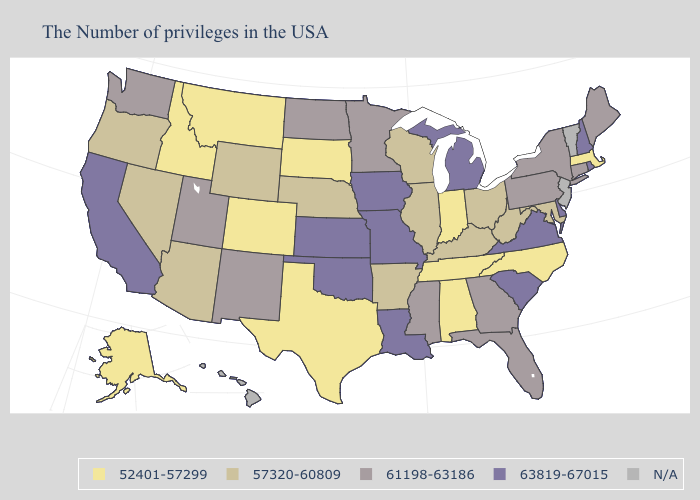Name the states that have a value in the range 57320-60809?
Quick response, please. Maryland, West Virginia, Ohio, Kentucky, Wisconsin, Illinois, Arkansas, Nebraska, Wyoming, Arizona, Nevada, Oregon. Does Pennsylvania have the highest value in the Northeast?
Answer briefly. No. What is the lowest value in the West?
Concise answer only. 52401-57299. Name the states that have a value in the range 52401-57299?
Keep it brief. Massachusetts, North Carolina, Indiana, Alabama, Tennessee, Texas, South Dakota, Colorado, Montana, Idaho, Alaska. Is the legend a continuous bar?
Write a very short answer. No. What is the lowest value in states that border North Carolina?
Write a very short answer. 52401-57299. What is the value of Delaware?
Write a very short answer. 63819-67015. Does South Carolina have the lowest value in the South?
Keep it brief. No. Does Indiana have the lowest value in the USA?
Quick response, please. Yes. Among the states that border Alabama , which have the lowest value?
Short answer required. Tennessee. What is the value of Wisconsin?
Concise answer only. 57320-60809. Name the states that have a value in the range 52401-57299?
Answer briefly. Massachusetts, North Carolina, Indiana, Alabama, Tennessee, Texas, South Dakota, Colorado, Montana, Idaho, Alaska. Among the states that border Maine , which have the lowest value?
Concise answer only. New Hampshire. 